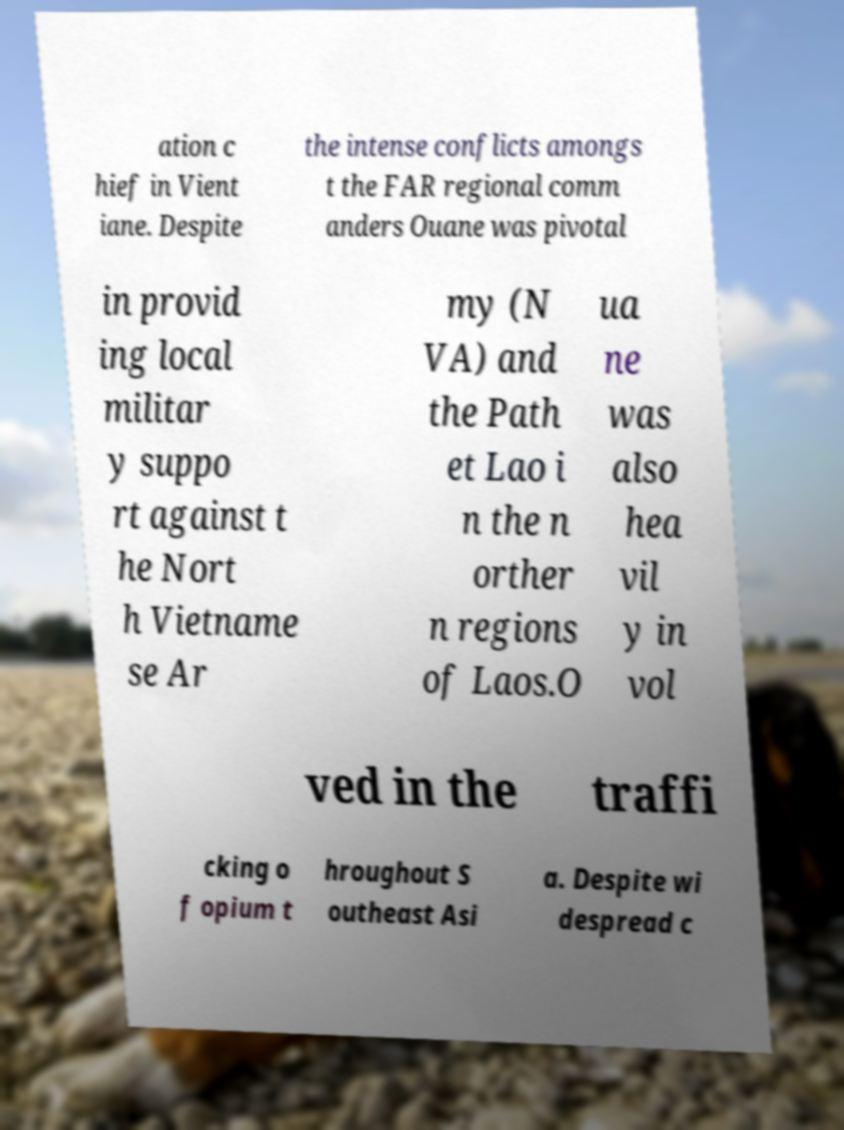For documentation purposes, I need the text within this image transcribed. Could you provide that? ation c hief in Vient iane. Despite the intense conflicts amongs t the FAR regional comm anders Ouane was pivotal in provid ing local militar y suppo rt against t he Nort h Vietname se Ar my (N VA) and the Path et Lao i n the n orther n regions of Laos.O ua ne was also hea vil y in vol ved in the traffi cking o f opium t hroughout S outheast Asi a. Despite wi despread c 